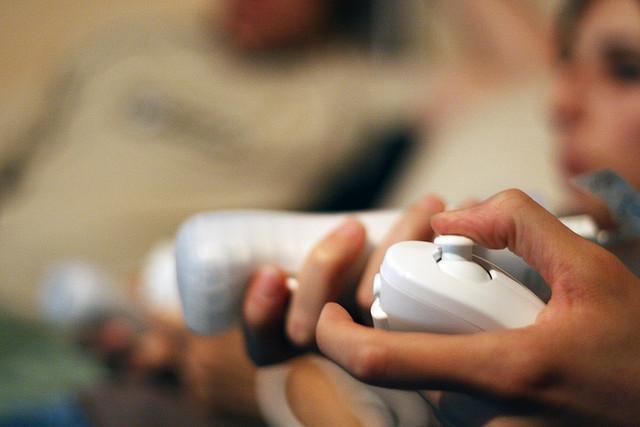How many people are there?
Give a very brief answer. 3. How many remotes are visible?
Give a very brief answer. 3. 